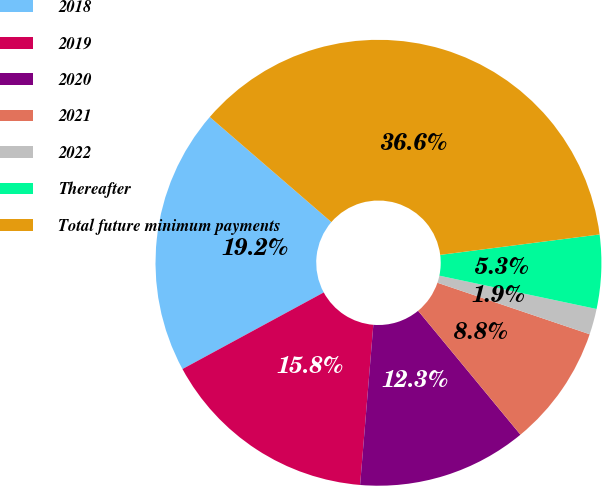Convert chart. <chart><loc_0><loc_0><loc_500><loc_500><pie_chart><fcel>2018<fcel>2019<fcel>2020<fcel>2021<fcel>2022<fcel>Thereafter<fcel>Total future minimum payments<nl><fcel>19.25%<fcel>15.78%<fcel>12.3%<fcel>8.82%<fcel>1.87%<fcel>5.35%<fcel>36.63%<nl></chart> 